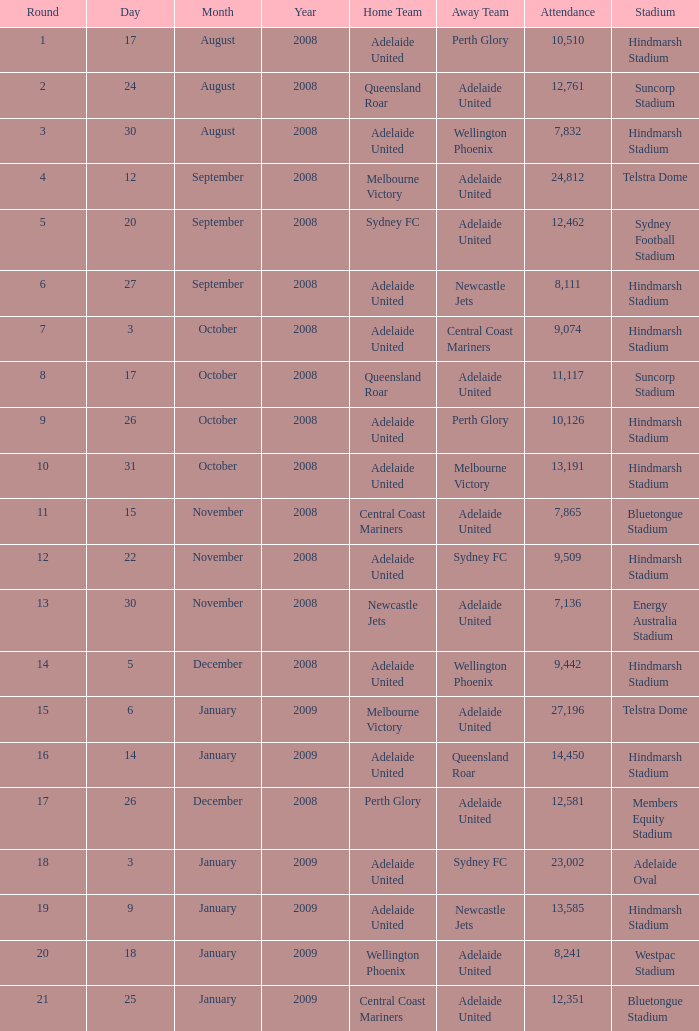What is the round when 11,117 people attended the game on 26 October 2008? 9.0. 